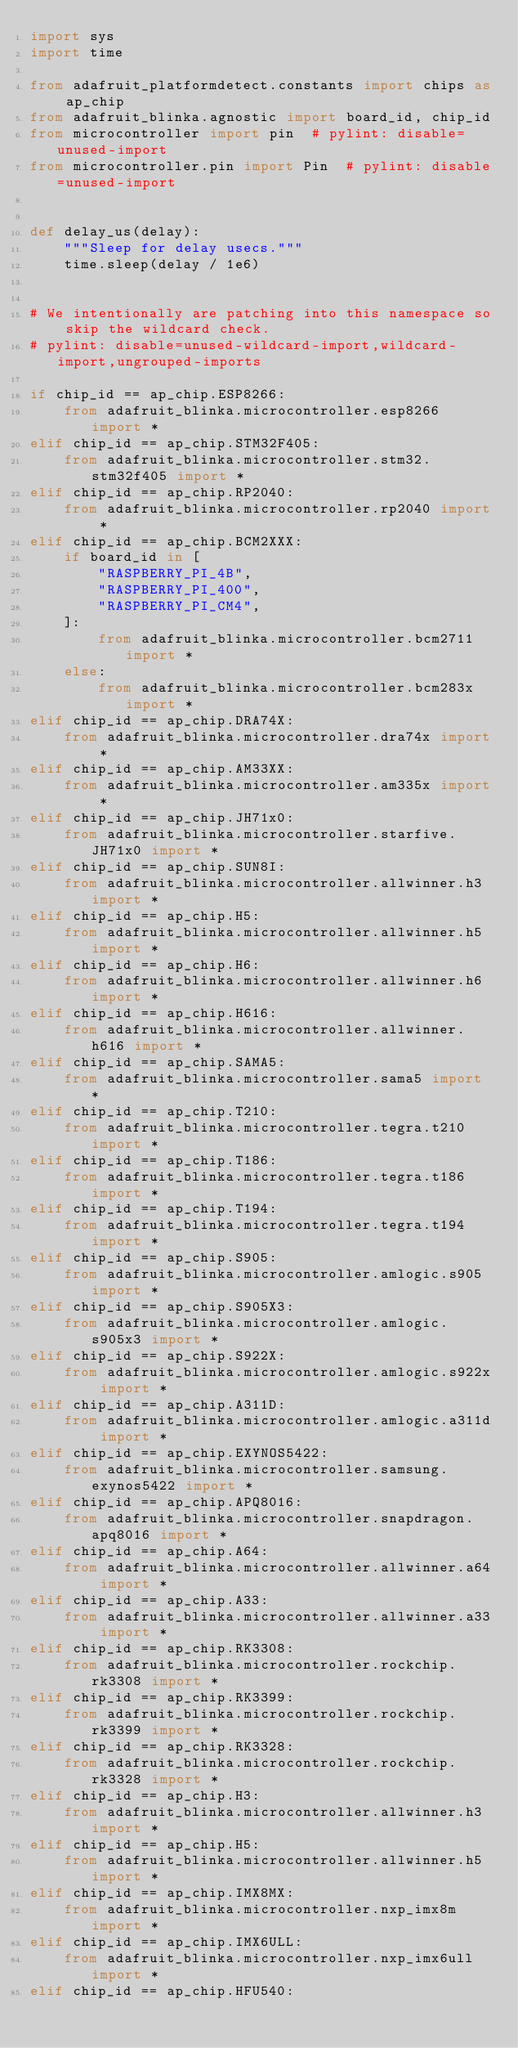Convert code to text. <code><loc_0><loc_0><loc_500><loc_500><_Python_>import sys
import time

from adafruit_platformdetect.constants import chips as ap_chip
from adafruit_blinka.agnostic import board_id, chip_id
from microcontroller import pin  # pylint: disable=unused-import
from microcontroller.pin import Pin  # pylint: disable=unused-import


def delay_us(delay):
    """Sleep for delay usecs."""
    time.sleep(delay / 1e6)


# We intentionally are patching into this namespace so skip the wildcard check.
# pylint: disable=unused-wildcard-import,wildcard-import,ungrouped-imports

if chip_id == ap_chip.ESP8266:
    from adafruit_blinka.microcontroller.esp8266 import *
elif chip_id == ap_chip.STM32F405:
    from adafruit_blinka.microcontroller.stm32.stm32f405 import *
elif chip_id == ap_chip.RP2040:
    from adafruit_blinka.microcontroller.rp2040 import *
elif chip_id == ap_chip.BCM2XXX:
    if board_id in [
        "RASPBERRY_PI_4B",
        "RASPBERRY_PI_400",
        "RASPBERRY_PI_CM4",
    ]:
        from adafruit_blinka.microcontroller.bcm2711 import *
    else:
        from adafruit_blinka.microcontroller.bcm283x import *
elif chip_id == ap_chip.DRA74X:
    from adafruit_blinka.microcontroller.dra74x import *
elif chip_id == ap_chip.AM33XX:
    from adafruit_blinka.microcontroller.am335x import *
elif chip_id == ap_chip.JH71x0:
    from adafruit_blinka.microcontroller.starfive.JH71x0 import *
elif chip_id == ap_chip.SUN8I:
    from adafruit_blinka.microcontroller.allwinner.h3 import *
elif chip_id == ap_chip.H5:
    from adafruit_blinka.microcontroller.allwinner.h5 import *
elif chip_id == ap_chip.H6:
    from adafruit_blinka.microcontroller.allwinner.h6 import *
elif chip_id == ap_chip.H616:
    from adafruit_blinka.microcontroller.allwinner.h616 import *
elif chip_id == ap_chip.SAMA5:
    from adafruit_blinka.microcontroller.sama5 import *
elif chip_id == ap_chip.T210:
    from adafruit_blinka.microcontroller.tegra.t210 import *
elif chip_id == ap_chip.T186:
    from adafruit_blinka.microcontroller.tegra.t186 import *
elif chip_id == ap_chip.T194:
    from adafruit_blinka.microcontroller.tegra.t194 import *
elif chip_id == ap_chip.S905:
    from adafruit_blinka.microcontroller.amlogic.s905 import *
elif chip_id == ap_chip.S905X3:
    from adafruit_blinka.microcontroller.amlogic.s905x3 import *
elif chip_id == ap_chip.S922X:
    from adafruit_blinka.microcontroller.amlogic.s922x import *
elif chip_id == ap_chip.A311D:
    from adafruit_blinka.microcontroller.amlogic.a311d import *
elif chip_id == ap_chip.EXYNOS5422:
    from adafruit_blinka.microcontroller.samsung.exynos5422 import *
elif chip_id == ap_chip.APQ8016:
    from adafruit_blinka.microcontroller.snapdragon.apq8016 import *
elif chip_id == ap_chip.A64:
    from adafruit_blinka.microcontroller.allwinner.a64 import *
elif chip_id == ap_chip.A33:
    from adafruit_blinka.microcontroller.allwinner.a33 import *
elif chip_id == ap_chip.RK3308:
    from adafruit_blinka.microcontroller.rockchip.rk3308 import *
elif chip_id == ap_chip.RK3399:
    from adafruit_blinka.microcontroller.rockchip.rk3399 import *
elif chip_id == ap_chip.RK3328:
    from adafruit_blinka.microcontroller.rockchip.rk3328 import *
elif chip_id == ap_chip.H3:
    from adafruit_blinka.microcontroller.allwinner.h3 import *
elif chip_id == ap_chip.H5:
    from adafruit_blinka.microcontroller.allwinner.h5 import *
elif chip_id == ap_chip.IMX8MX:
    from adafruit_blinka.microcontroller.nxp_imx8m import *
elif chip_id == ap_chip.IMX6ULL:
    from adafruit_blinka.microcontroller.nxp_imx6ull import *
elif chip_id == ap_chip.HFU540:</code> 